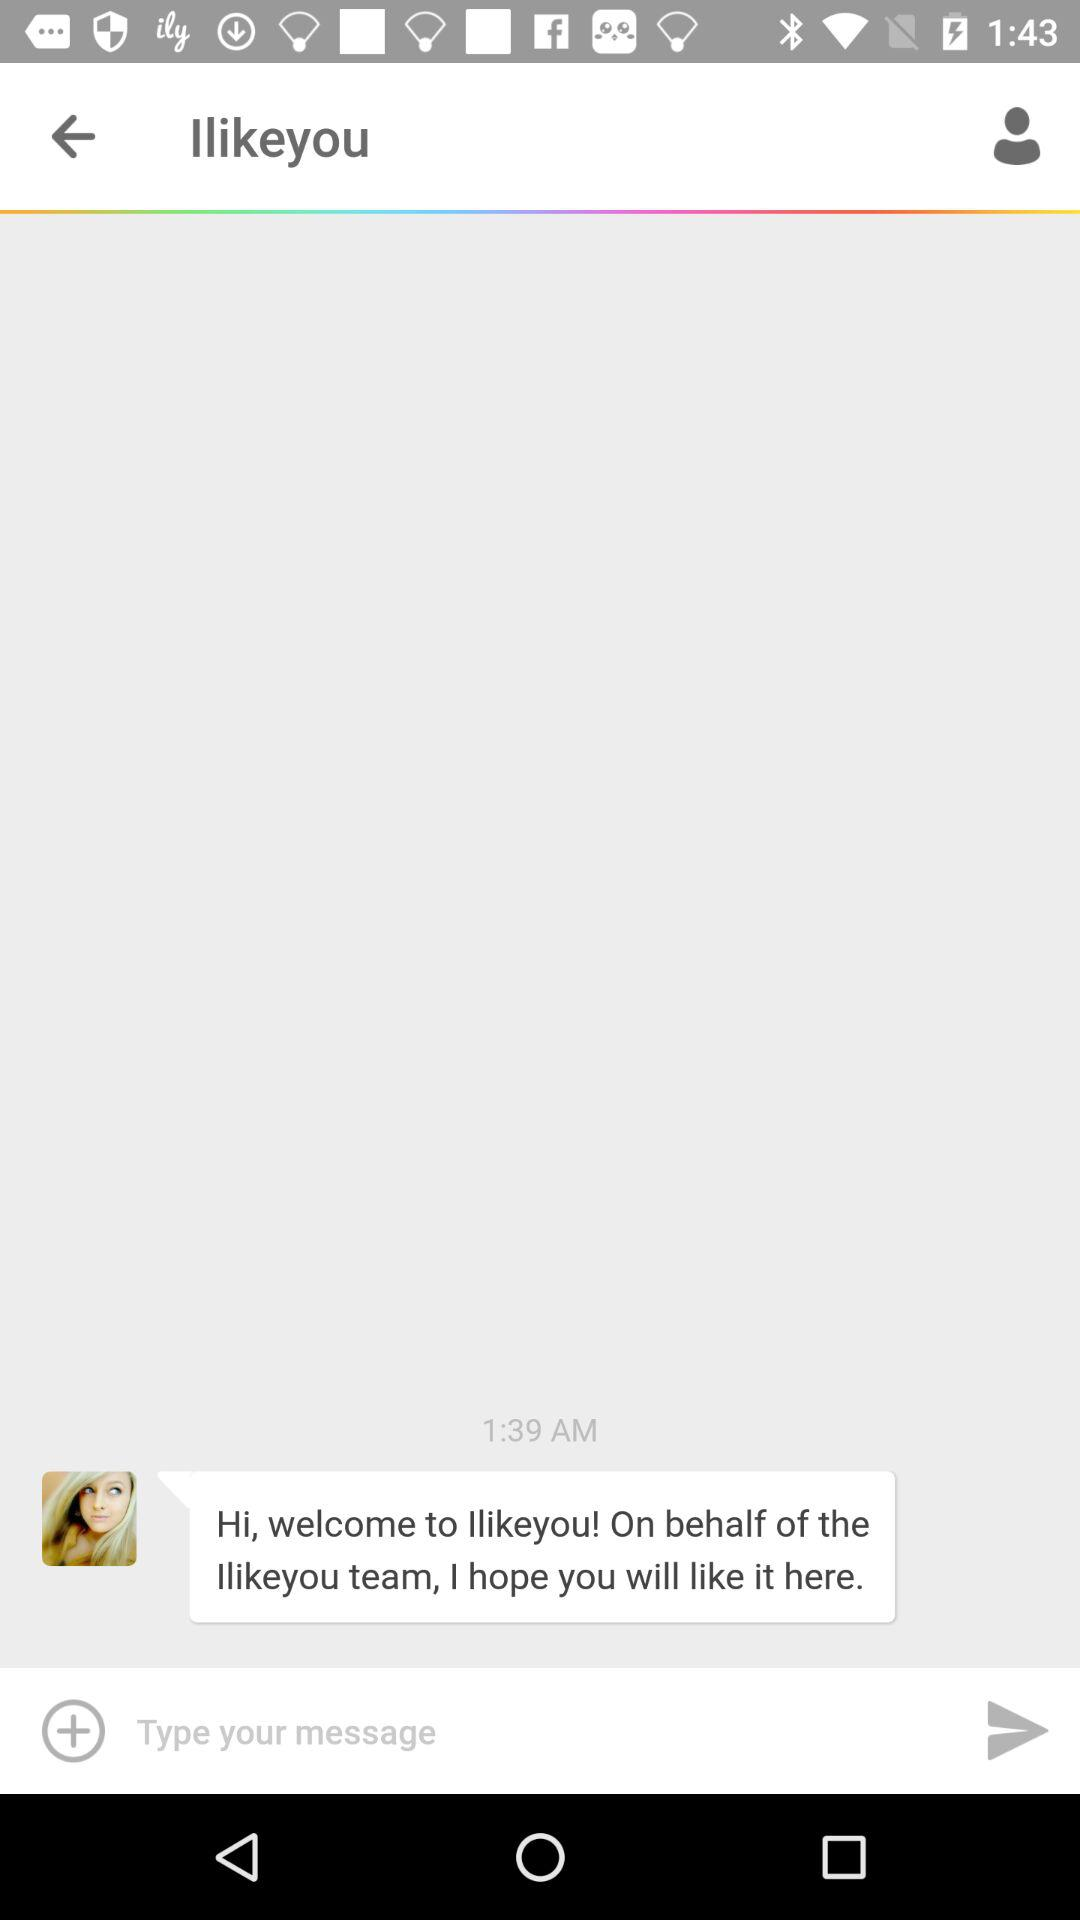When was the message received? The message was received by 1:39 AM. 